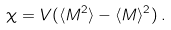<formula> <loc_0><loc_0><loc_500><loc_500>\chi = V ( \langle M ^ { 2 } \rangle - \langle M \rangle ^ { 2 } ) \, .</formula> 